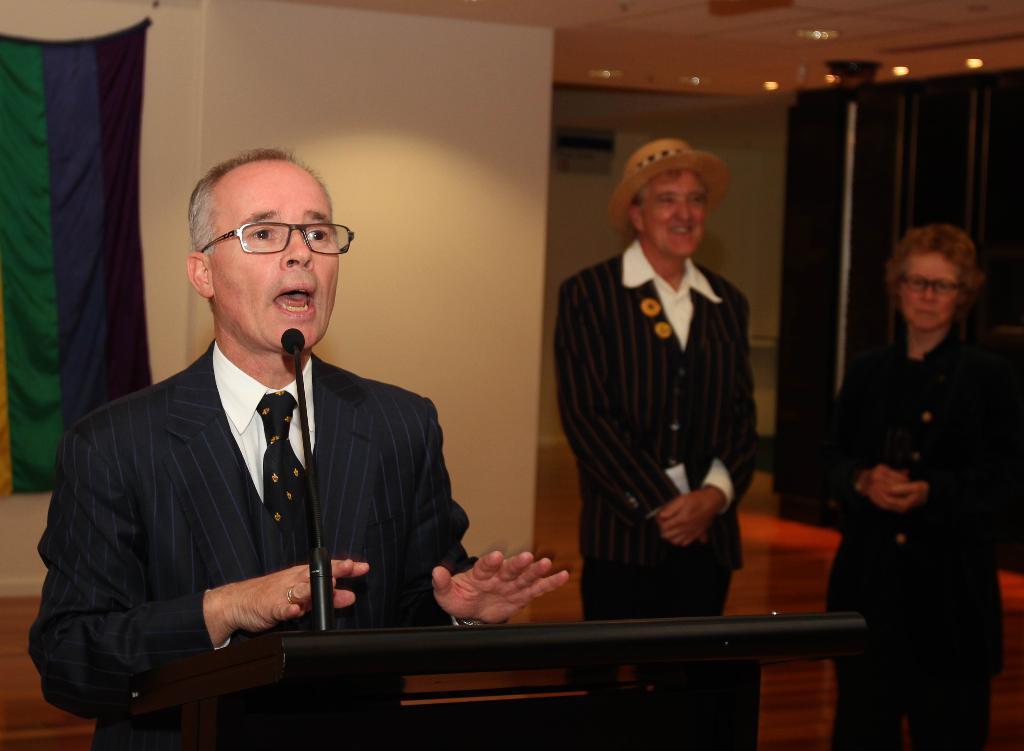In one or two sentences, can you explain what this image depicts? This picture might be taken inside a conference hall. In this image, on the left side, we can see a man wearing a blue color shirt is standing in front of the table. On that table, we can see a microphone. On the left side, we can see a cloth. On the right side, we can see two people man and woman. At the top, we can see a roof with few lights. 